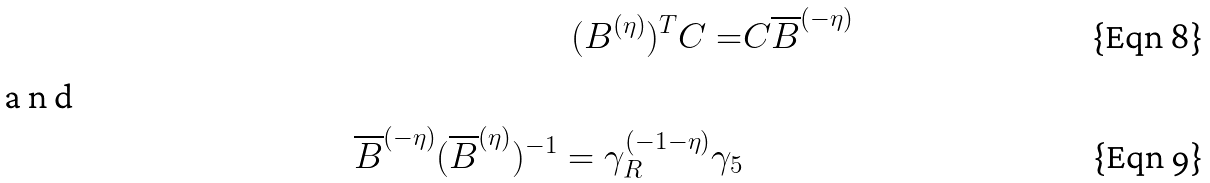<formula> <loc_0><loc_0><loc_500><loc_500>( B ^ { ( \eta ) } ) ^ { T } C = & C \overline { B } ^ { ( - \eta ) } \\ \intertext { a n d } \overline { B } ^ { ( - \eta ) } ( \overline { B } ^ { ( \eta ) } ) ^ { - 1 } = \gamma _ { R } ^ { ( - 1 - \eta ) } \gamma _ { 5 }</formula> 